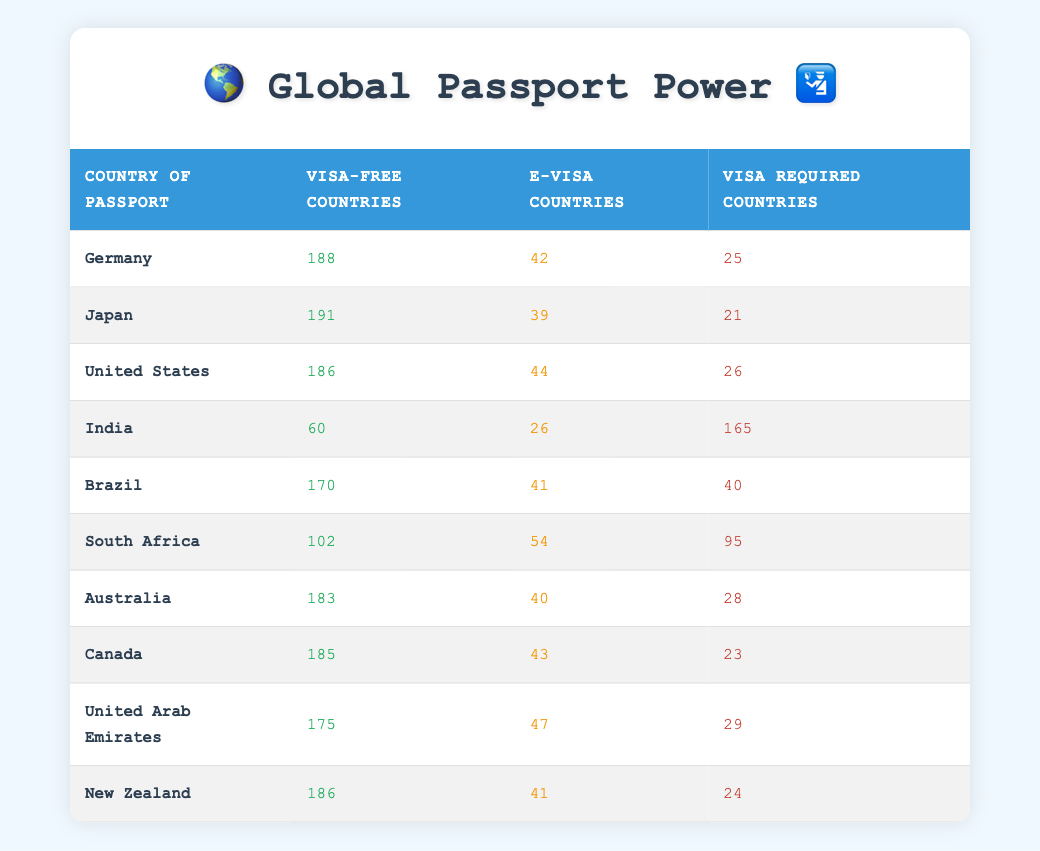What is the highest number of visa-free countries available to a passport holder? The table indicates that Japan offers the most visa-free access with 191 countries. This is found by scanning the "Visa-free Countries" column and identifying the maximum value.
Answer: 191 Which country requires the most visas for entry? India has the highest number of visa required countries listed at 165. This is determined by reviewing the "Visa Required Countries" column and locating the maximum value.
Answer: 165 What is the total number of e-visa countries for Germany, Australia, and Canada combined? To find the total, we sum the e-visa countries for these three countries: Germany (42) + Australia (40) + Canada (43) = 125.
Answer: 125 True or False: The United States offers more e-visa countries than Brazil. The United States has 44 e-visa countries while Brazil has 41. Comparing these values shows that the statement is true.
Answer: True What is the average number of visa-free countries among the countries listed in the table? The total number of visa-free countries across all countries is 188 + 191 + 186 + 60 + 170 + 102 + 183 + 185 + 175 + 186 = 1,581. There are 10 countries, so the average is 1,581 / 10 = 158.1.
Answer: 158.1 Which passport holder has the least access to visa-free countries? India has the least access with only 60 visa-free countries, as derived from the "Visa-free Countries" column by identifying the minimum value.
Answer: 60 If a traveler holds a German passport, how many countries would they need a visa to enter? According to the data for Germany, 25 countries require a visa. This is a direct reference to the "Visa Required Countries" column for Germany.
Answer: 25 How many more visa-required countries does South Africa have compared to Canada? South Africa has 95 visa-required countries and Canada has 23. The difference is calculated as 95 - 23 = 72.
Answer: 72 